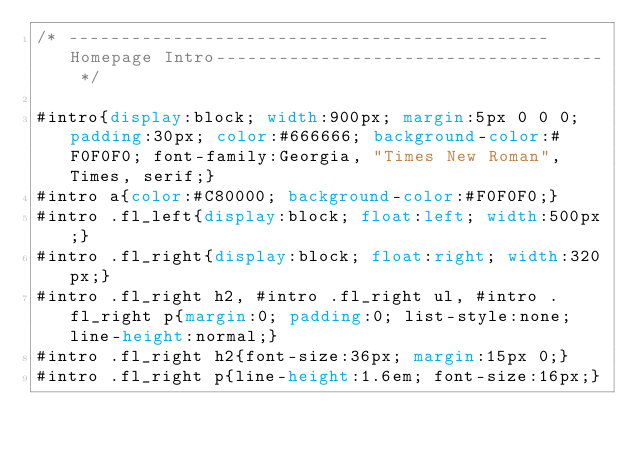<code> <loc_0><loc_0><loc_500><loc_500><_CSS_>/* ----------------------------------------------Homepage Intro------------------------------------- */

#intro{display:block; width:900px; margin:5px 0 0 0; padding:30px; color:#666666; background-color:#F0F0F0; font-family:Georgia, "Times New Roman", Times, serif;}
#intro a{color:#C80000; background-color:#F0F0F0;}
#intro .fl_left{display:block; float:left; width:500px;}
#intro .fl_right{display:block; float:right; width:320px;}
#intro .fl_right h2, #intro .fl_right ul, #intro .fl_right p{margin:0; padding:0; list-style:none; line-height:normal;}
#intro .fl_right h2{font-size:36px; margin:15px 0;}
#intro .fl_right p{line-height:1.6em; font-size:16px;}
</code> 